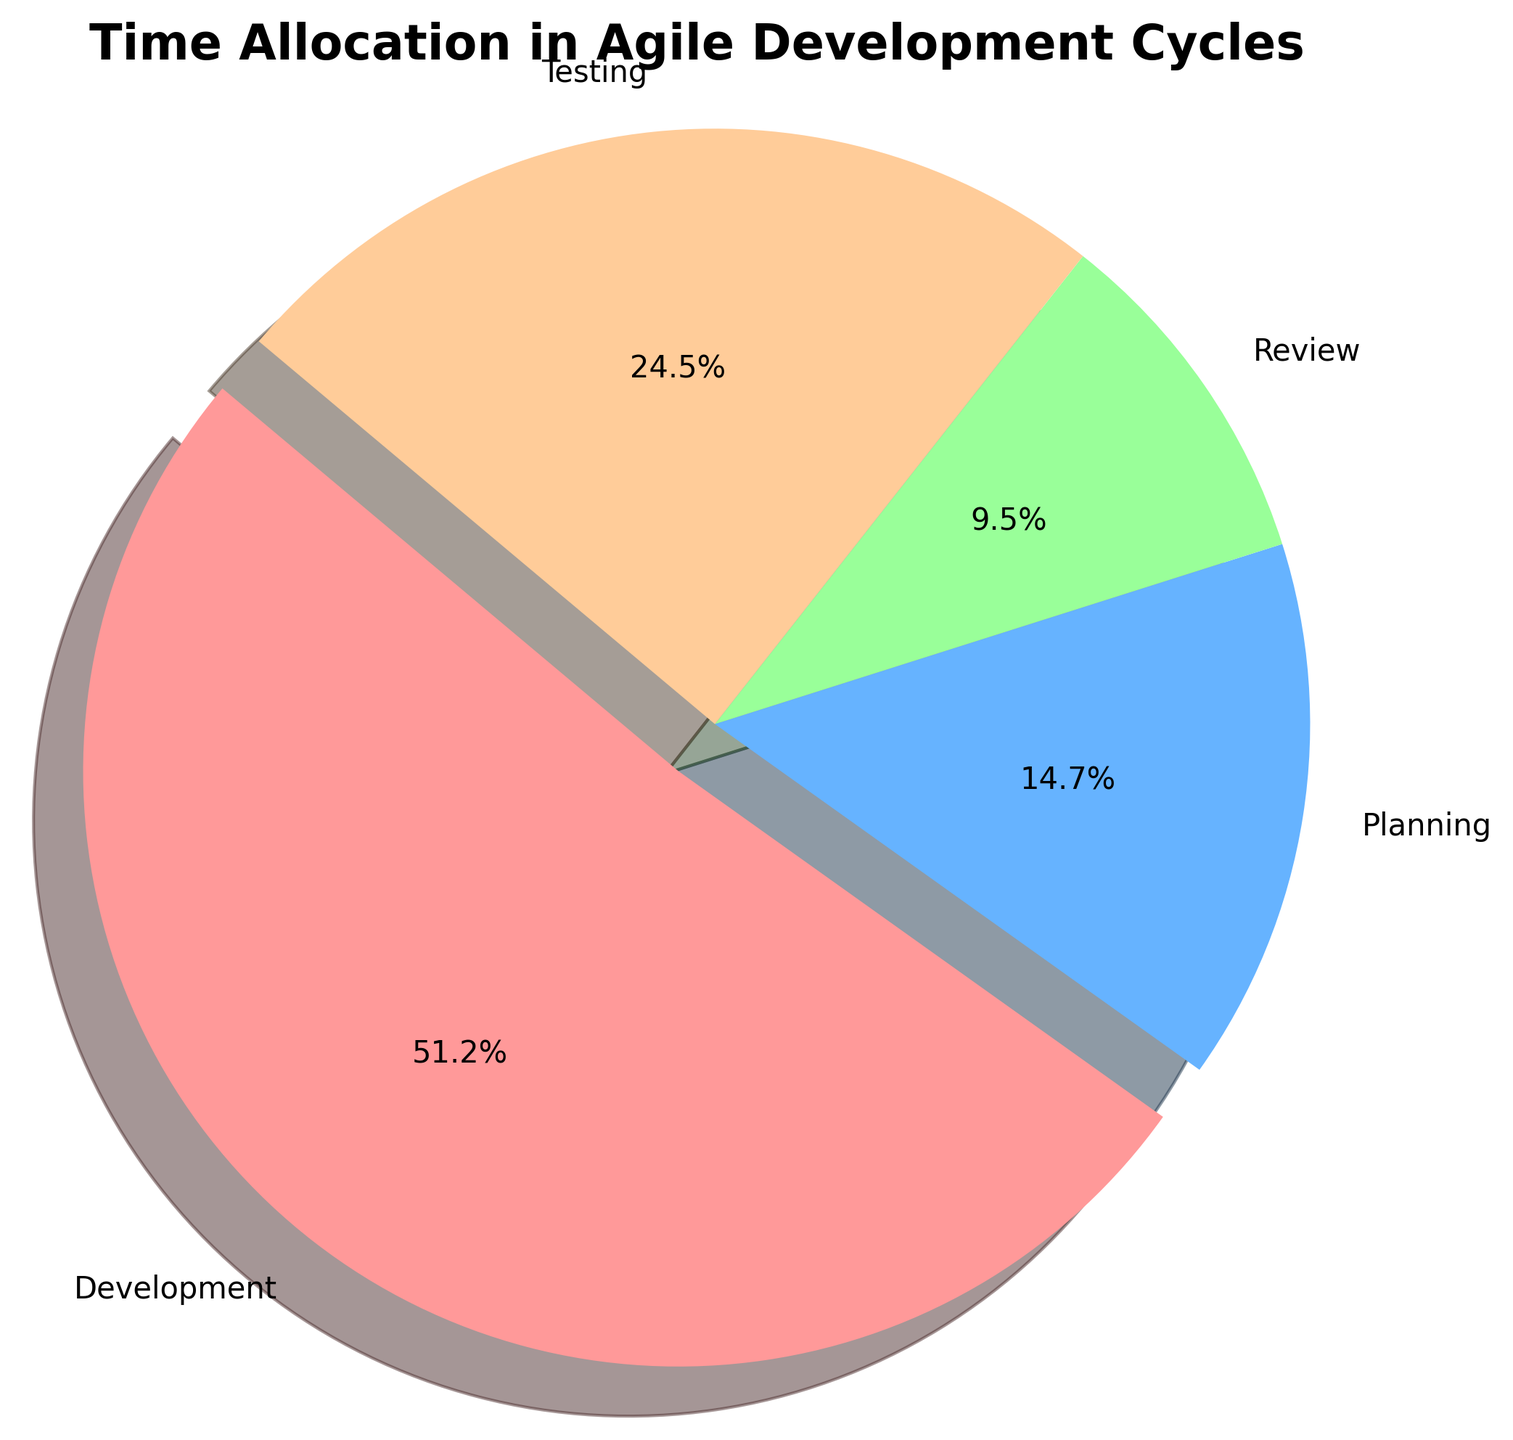Which category has the highest percentage allocation in the agile development cycles? By looking at the pie chart, the largest slice of the pie, which is typically the most visually prominent, represents the category with the highest percentage allocation. In this case, the 'Development' slice is the largest.
Answer: Development What percentage of time is allocated to Testing compared to Planning? The percentage of time for Testing can be seen from its slice, and similarly for Planning. In the chart, Testing is allocated 25%, while Planning is allocated 15%. Comparing these two, Testing has a greater percentage of time allocation.
Answer: Testing What is the total percentage of time allocated to non-development activities? To find the total percentage of non-development activities, sum up the percentages allocated to Planning, Testing, and Review. From the chart, we have 15% (Planning) + 25% (Testing) + 10% (Review) = 50%.
Answer: 50% Which two categories have the smallest time allocation, and what is their combined percentage? From the pie chart, the smallest slices represent the categories with the smallest time allocations. These are 'Review' (10%) and 'Planning' (15%). Adding these together gives 10% + 15% = 25%.
Answer: Review and Planning, 25% Are there any categories with equal time allocations? By inspecting the pie chart, we compare the percentages for each category. Both Review and Planning have one slice each labeled with 10%.
Answer: Review and Planning How does the time allocation for Development compare to the combined allocation for Planning and Review? The pie chart shows that Development has 50% time allocation. Planning and Review together have 15% (Planning) + 10% (Review) = 25%. Development has double the time allocation compared to Planning and Review combined.
Answer: Development is double In terms of visual size, which category's slice appears to be the smallest? By observing the pie chart, the smallest slice visually stands out and is typically lighter in shade or smaller in view. In this case, the 'Review' slice is the smallest.
Answer: Review If the percentages for Planning and Testing were swapped, how would the new time allocation look visually? Currently, Planning is 15% and Testing is 25%. Swapping them would mean Planning gets the larger slice (25%) and Testing gets the smaller slice (15%). Visually, this would make Planning's slice larger and Testing's slice smaller.
Answer: Planning would be larger, Testing smaller What is the difference in percentage between the largest and smallest time allocations? The largest time allocation is Development at 50% and the smallest is Review at 10%. The difference is calculated as 50% - 10% = 40%.
Answer: 40% What can you infer about the focus of the agile development cycles based on the time allocations? The pie chart shows that Development has the highest allocation at 50%, indicating a strong focus on this phase. Other phases (Planning, Testing, Review) have lower allocations, suggesting that while they are important, they require less time comparatively.
Answer: Strong focus on Development 